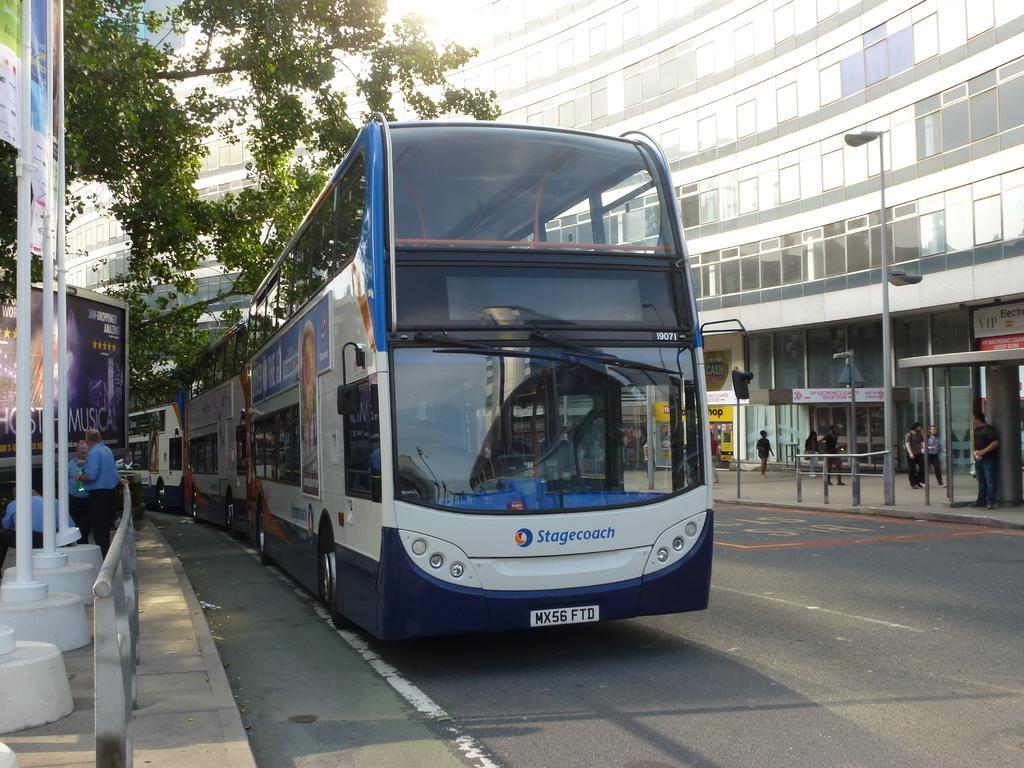In one or two sentences, can you explain what this image depicts? This image consists of buses parked in a line. At the bottom, there is a road. To the right, there is a building along with windows. To the left, there is a tree and hoardings along with pavement. 